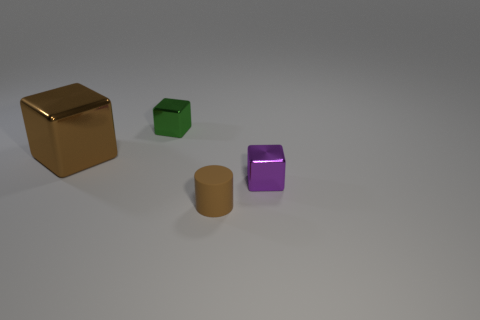Is the color of the large shiny object the same as the matte thing?
Keep it short and to the point. Yes. The brown thing that is the same size as the green cube is what shape?
Your answer should be very brief. Cylinder. There is a small cube that is in front of the tiny metallic block to the left of the metallic thing that is in front of the large metal cube; what is it made of?
Give a very brief answer. Metal. There is a small metal thing on the left side of the rubber cylinder; does it have the same shape as the rubber object that is to the right of the green cube?
Keep it short and to the point. No. What number of other things are made of the same material as the tiny cylinder?
Make the answer very short. 0. Is the material of the tiny purple object that is to the right of the big brown metallic object the same as the cube to the left of the green cube?
Offer a terse response. Yes. The green object that is the same material as the brown block is what shape?
Provide a succinct answer. Cube. Is there any other thing that is the same color as the large shiny thing?
Your response must be concise. Yes. What number of tiny matte cylinders are there?
Offer a terse response. 1. There is a tiny object that is on the left side of the small purple shiny cube and behind the tiny matte object; what shape is it?
Make the answer very short. Cube. 